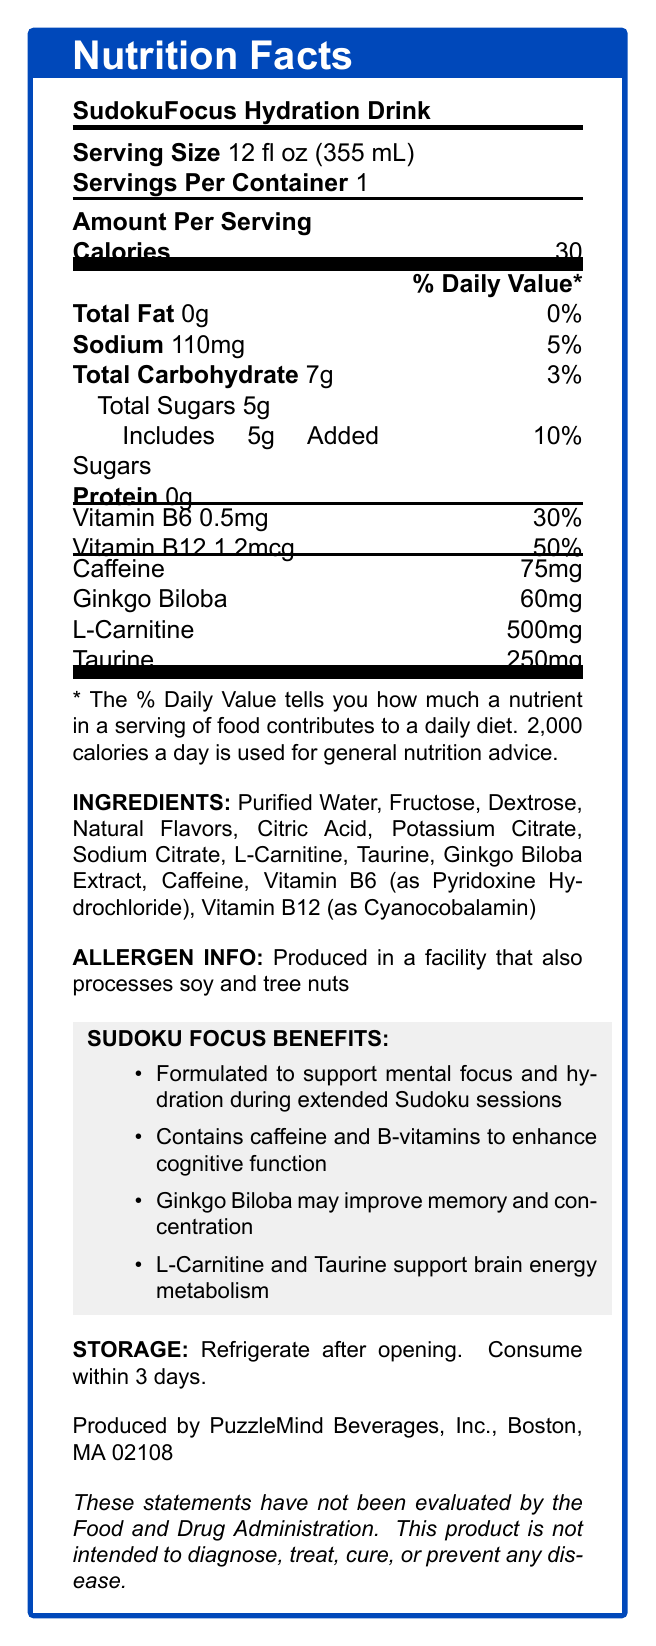what is the serving size of SudokuFocus Hydration Drink? The serving size is explicitly listed as "12 fl oz (355 mL)" in the document.
Answer: 12 fl oz (355 mL) how many calories are in one serving? The document specifies that there are 30 calories per serving.
Answer: 30 how much sodium does one serving contain? The document states that each serving contains 110mg of sodium.
Answer: 110mg what percentage of the daily value of added sugars does one serving include? Under the "Total Sugars" section, it is noted that the added sugars contribute 10% of the daily value.
Answer: 10% what is the amount of caffeine in one serving? The amount of caffeine in one serving is listed as 75mg.
Answer: 75mg which vitamins are included and what are their respective daily values? The document lists Vitamin B6 with a 30% daily value and Vitamin B12 with a 50% daily value.
Answer: Vitamin B6: 30%, Vitamin B12: 50% Which of the following is correct about the product? A. It contains protein. B. It is produced in a facility that processes peanuts. C. It is formulated to support mental focus. Option A is incorrect because the product lists 0g of protein. Option B is incorrect because it processes soy and tree nuts, not peanuts. Option C is correct as the product is stated to be formulated for mental focus.
Answer: C what are the inactive ingredients in SudokuFocus Hydration Drink? These ingredients are listed under the "INGREDIENTS" section excluding active components like L-Carnitine, Taurine, Ginkgo Biloba Extract, Caffeine, Vitamin B6, and Vitamin B12.
Answer: Purified Water, Fructose, Dextrose, Natural Flavors, Citric Acid, Potassium Citrate, Sodium Citrate how should you store the drink after opening? A. Store at room temperature. B. Store in the fridge. C. Freeze it. The storage instructions clearly state to refrigerate after opening.
Answer: B does one serving contain any protein? The document lists 0g of protein per serving, indicating no protein content.
Answer: No what is one of the functional benefits of Ginkgo Biloba in this product? The document lists that Ginkgo Biloba may improve memory and concentration under the "SUDOKU FOCUS BENEFITS" section.
Answer: It may improve memory and concentration. how much L-Carnitine is in one serving of the drink? The amount of L-Carnitine per serving is listed as 500mg.
Answer: 500mg true or false: the product is intended to diagnose, treat, cure, or prevent any disease. The disclaimer clearly states that the product is not intended to diagnose, treat, cure, or prevent any disease.
Answer: False summarize the primary purpose of SudokuFocus Hydration Drink. This summary includes the main goal of the drink, the key ingredients, and their intended benefits, providing a comprehensive overview of the product’s purpose.
Answer: The primary purpose of SudokuFocus Hydration Drink is to support mental focus and hydration during extended Sudoku sessions. It contains caffeine, B-vitamins, Ginkgo Biloba, L-Carnitine, and Taurine, which collectively enhance cognitive function, improve memory and concentration, and support brain energy metabolism. It is a low-calorie beverage with specific nutrients designed to benefit brain health and mental acuity. who is the manufacturer of this drink? The manufacturer information is listed at the bottom of the document stating it is produced by PuzzleMind Beverages, Inc., in Boston, MA 02108.
Answer: PuzzleMind Beverages, Inc., Boston, MA 02108 what is the recommended time frame to consume the drink after opening? The storage instructions specify that the drink should be consumed within 3 days after opening.
Answer: Within 3 days what is the daily value percentage for total fat in one serving? The document lists the total fat content as 0g with a daily value of 0%.
Answer: 0% How does taurine contribute to the benefits of the drink? According to the benefits section, taurine supports brain energy metabolism.
Answer: Supports brain energy metabolism what is the weight of the product? The document does not provide the total weight of the product; it only gives serving size and nutritional content per serving.
Answer: Not enough information which component is responsible for the flavoring of the drink? The ingredients list includes "Natural Flavors" which is responsible for the flavoring.
Answer: Natural Flavors 